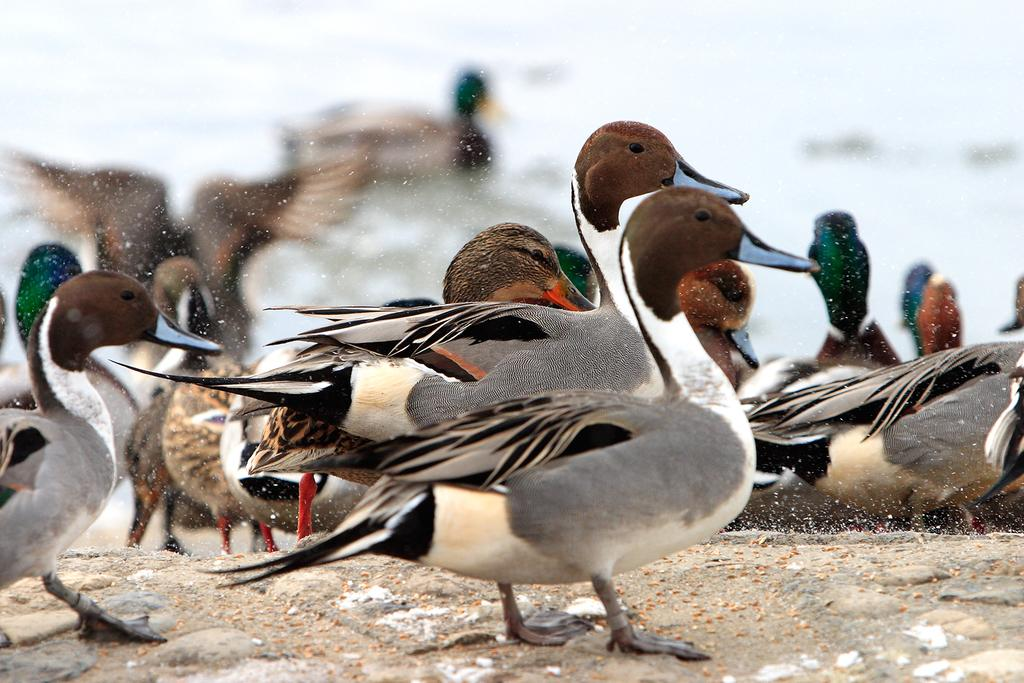What type of animals can be seen in the image? There are birds in the image. Can you describe the color of the birds? The birds are gray and brown in color. What else is visible in the image besides the birds? There is water visible in the image. How would you describe the color of the water? The water appears to be white in color. Can you see a roof in the image? There is no mention of a roof in the provided facts, so it cannot be seen in the image. 